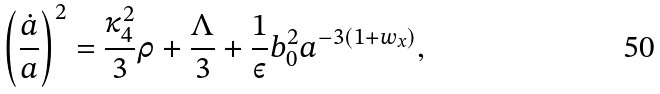Convert formula to latex. <formula><loc_0><loc_0><loc_500><loc_500>\left ( \frac { \dot { a } } { a } \right ) ^ { 2 } = \frac { \kappa _ { 4 } ^ { 2 } } { 3 } \rho + \frac { \Lambda } { 3 } + \frac { 1 } { \varepsilon } b _ { 0 } ^ { 2 } { a ^ { - 3 ( 1 + w _ { x } ) } } ,</formula> 